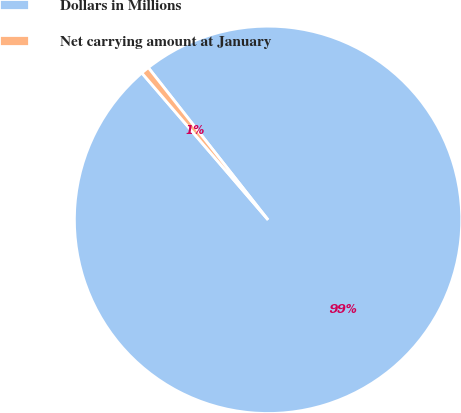<chart> <loc_0><loc_0><loc_500><loc_500><pie_chart><fcel>Dollars in Millions<fcel>Net carrying amount at January<nl><fcel>99.31%<fcel>0.69%<nl></chart> 